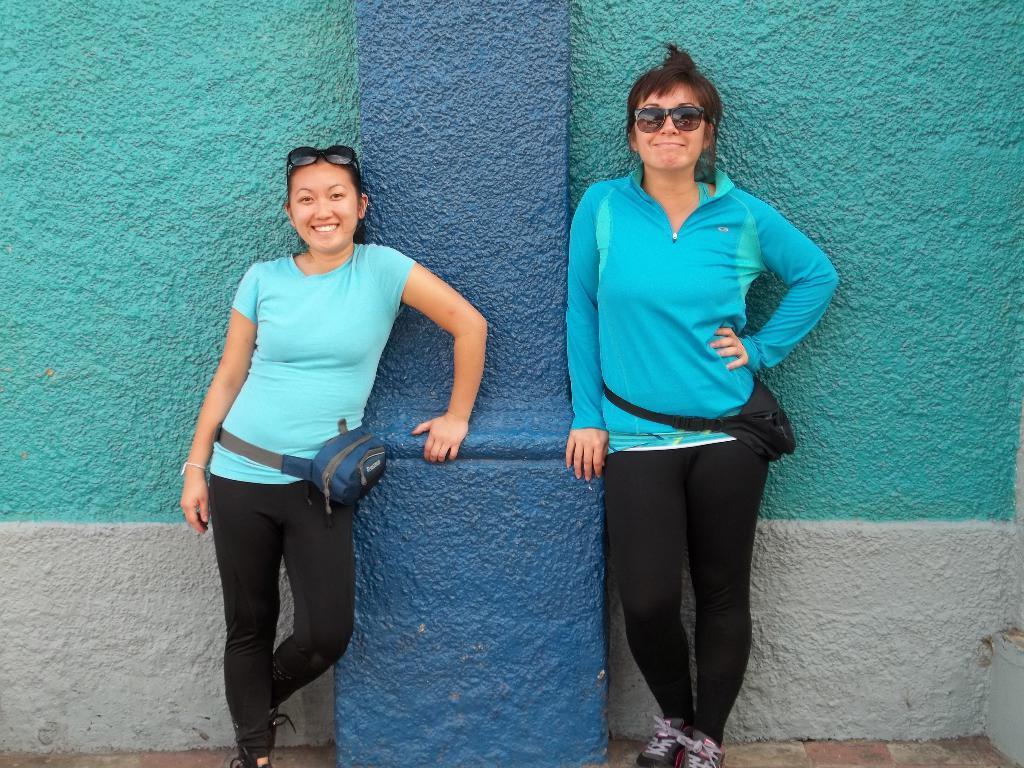Can you describe this image briefly? In this image we can see there are two persons standing on the ground. In the background, we can see the wall and pillar. 